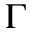Convert formula to latex. <formula><loc_0><loc_0><loc_500><loc_500>\Gamma</formula> 